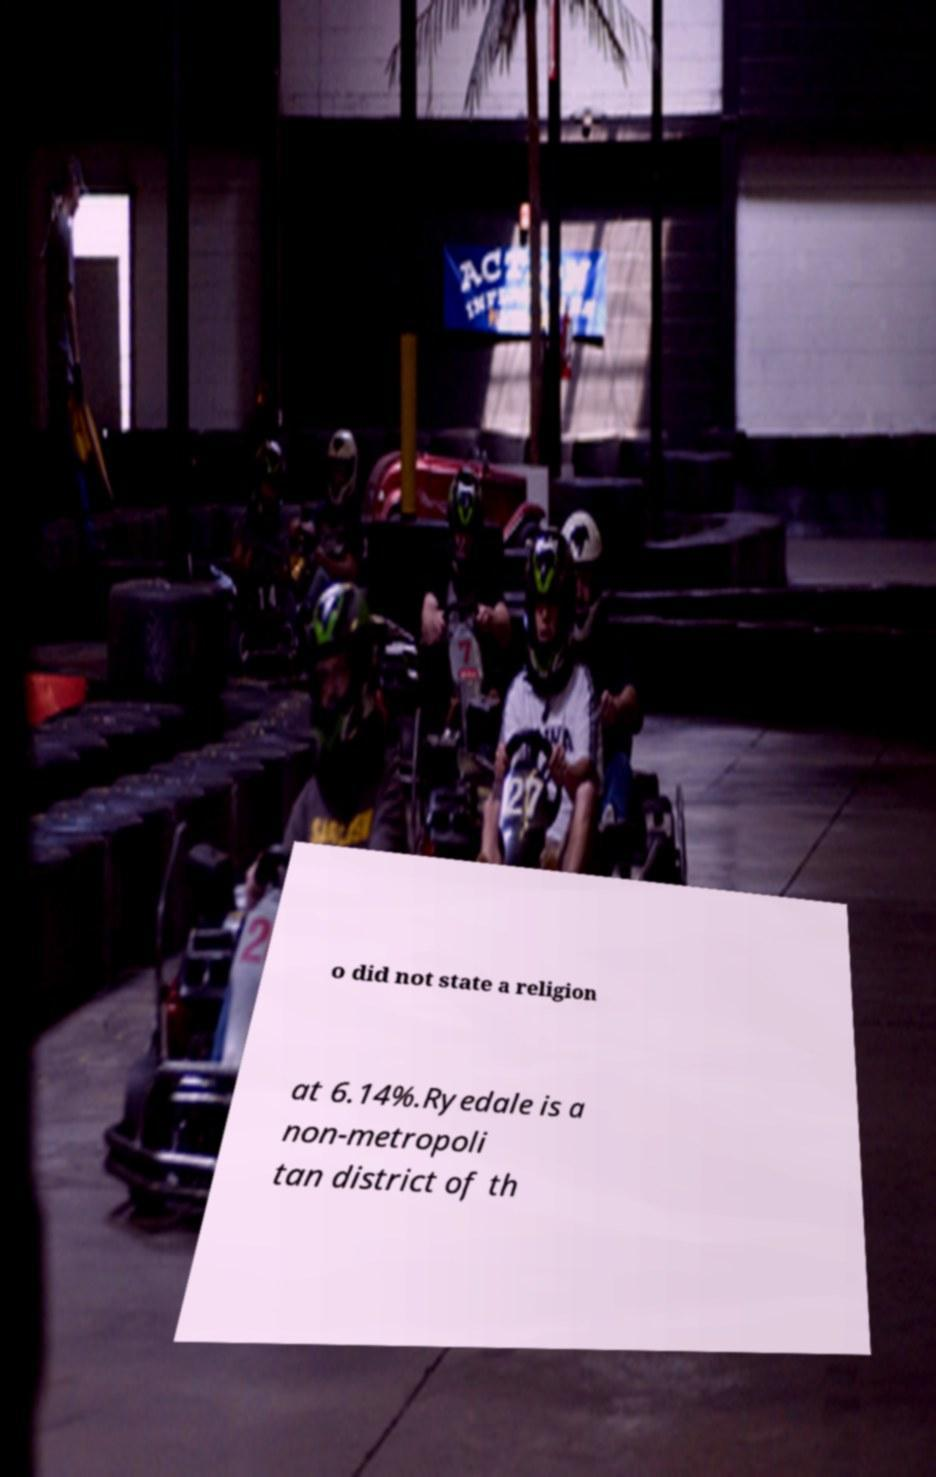Can you accurately transcribe the text from the provided image for me? o did not state a religion at 6.14%.Ryedale is a non-metropoli tan district of th 